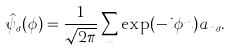Convert formula to latex. <formula><loc_0><loc_0><loc_500><loc_500>\hat { \psi } _ { \sigma } ( \phi ) = \frac { 1 } { \sqrt { 2 \pi } } \sum _ { n } \exp ( - i \phi n ) a _ { n \sigma } .</formula> 